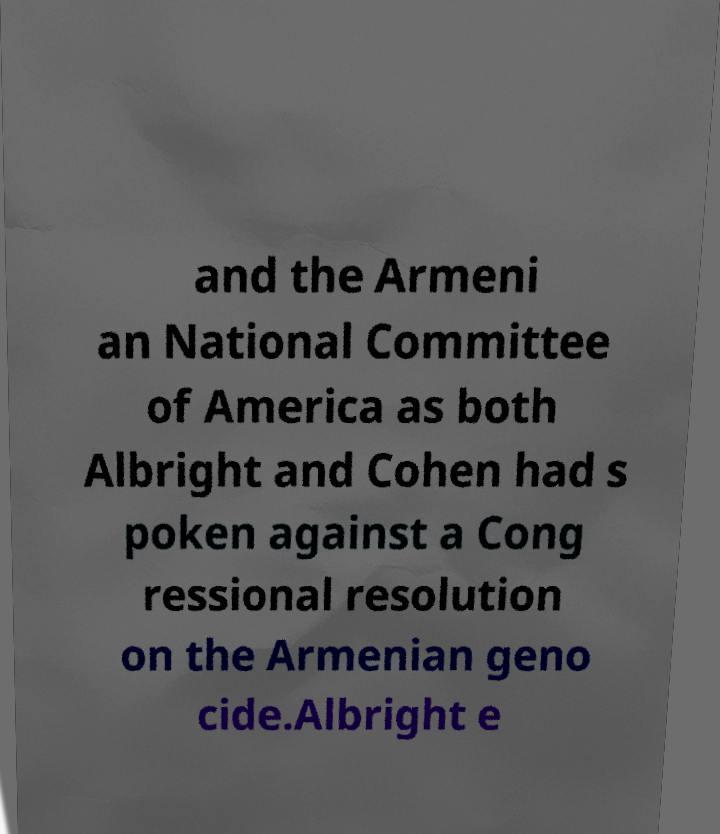Could you extract and type out the text from this image? and the Armeni an National Committee of America as both Albright and Cohen had s poken against a Cong ressional resolution on the Armenian geno cide.Albright e 